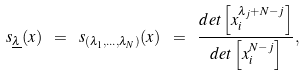Convert formula to latex. <formula><loc_0><loc_0><loc_500><loc_500>s _ { \underline { \lambda } } ( x ) \ = \ s _ { ( \lambda _ { 1 } , \dots , \lambda _ { N } ) } ( x ) \ = \ \frac { d e t \left [ x _ { i } ^ { \lambda _ { j } + N - j } \right ] } { d e t \left [ x _ { i } ^ { N - j } \right ] } ,</formula> 